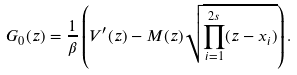<formula> <loc_0><loc_0><loc_500><loc_500>G _ { 0 } ( z ) = \frac { 1 } { \beta } \left ( V ^ { \prime } ( z ) - M ( z ) \sqrt { \prod _ { i = 1 } ^ { 2 s } ( z - x _ { i } ) } \right ) .</formula> 